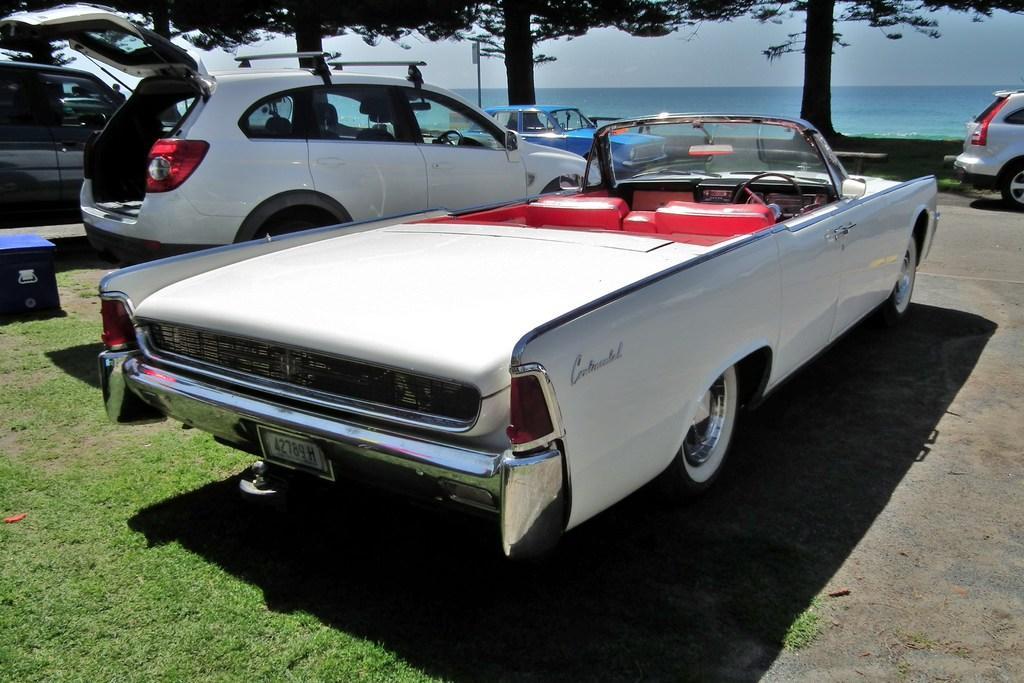In one or two sentences, can you explain what this image depicts? In the image there are different cars and behind the cars there are trees and behind the trees there is a water surface. 